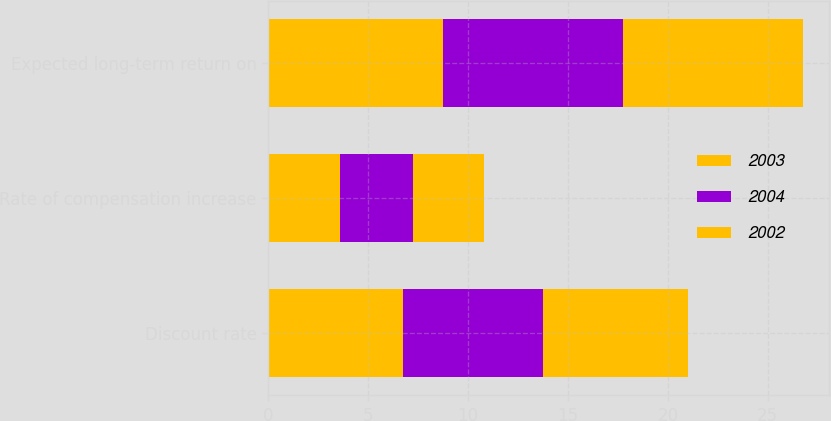Convert chart. <chart><loc_0><loc_0><loc_500><loc_500><stacked_bar_chart><ecel><fcel>Discount rate<fcel>Rate of compensation increase<fcel>Expected long-term return on<nl><fcel>2003<fcel>6.75<fcel>3.6<fcel>8.75<nl><fcel>2004<fcel>7<fcel>3.62<fcel>9<nl><fcel>2002<fcel>7.25<fcel>3.6<fcel>9<nl></chart> 